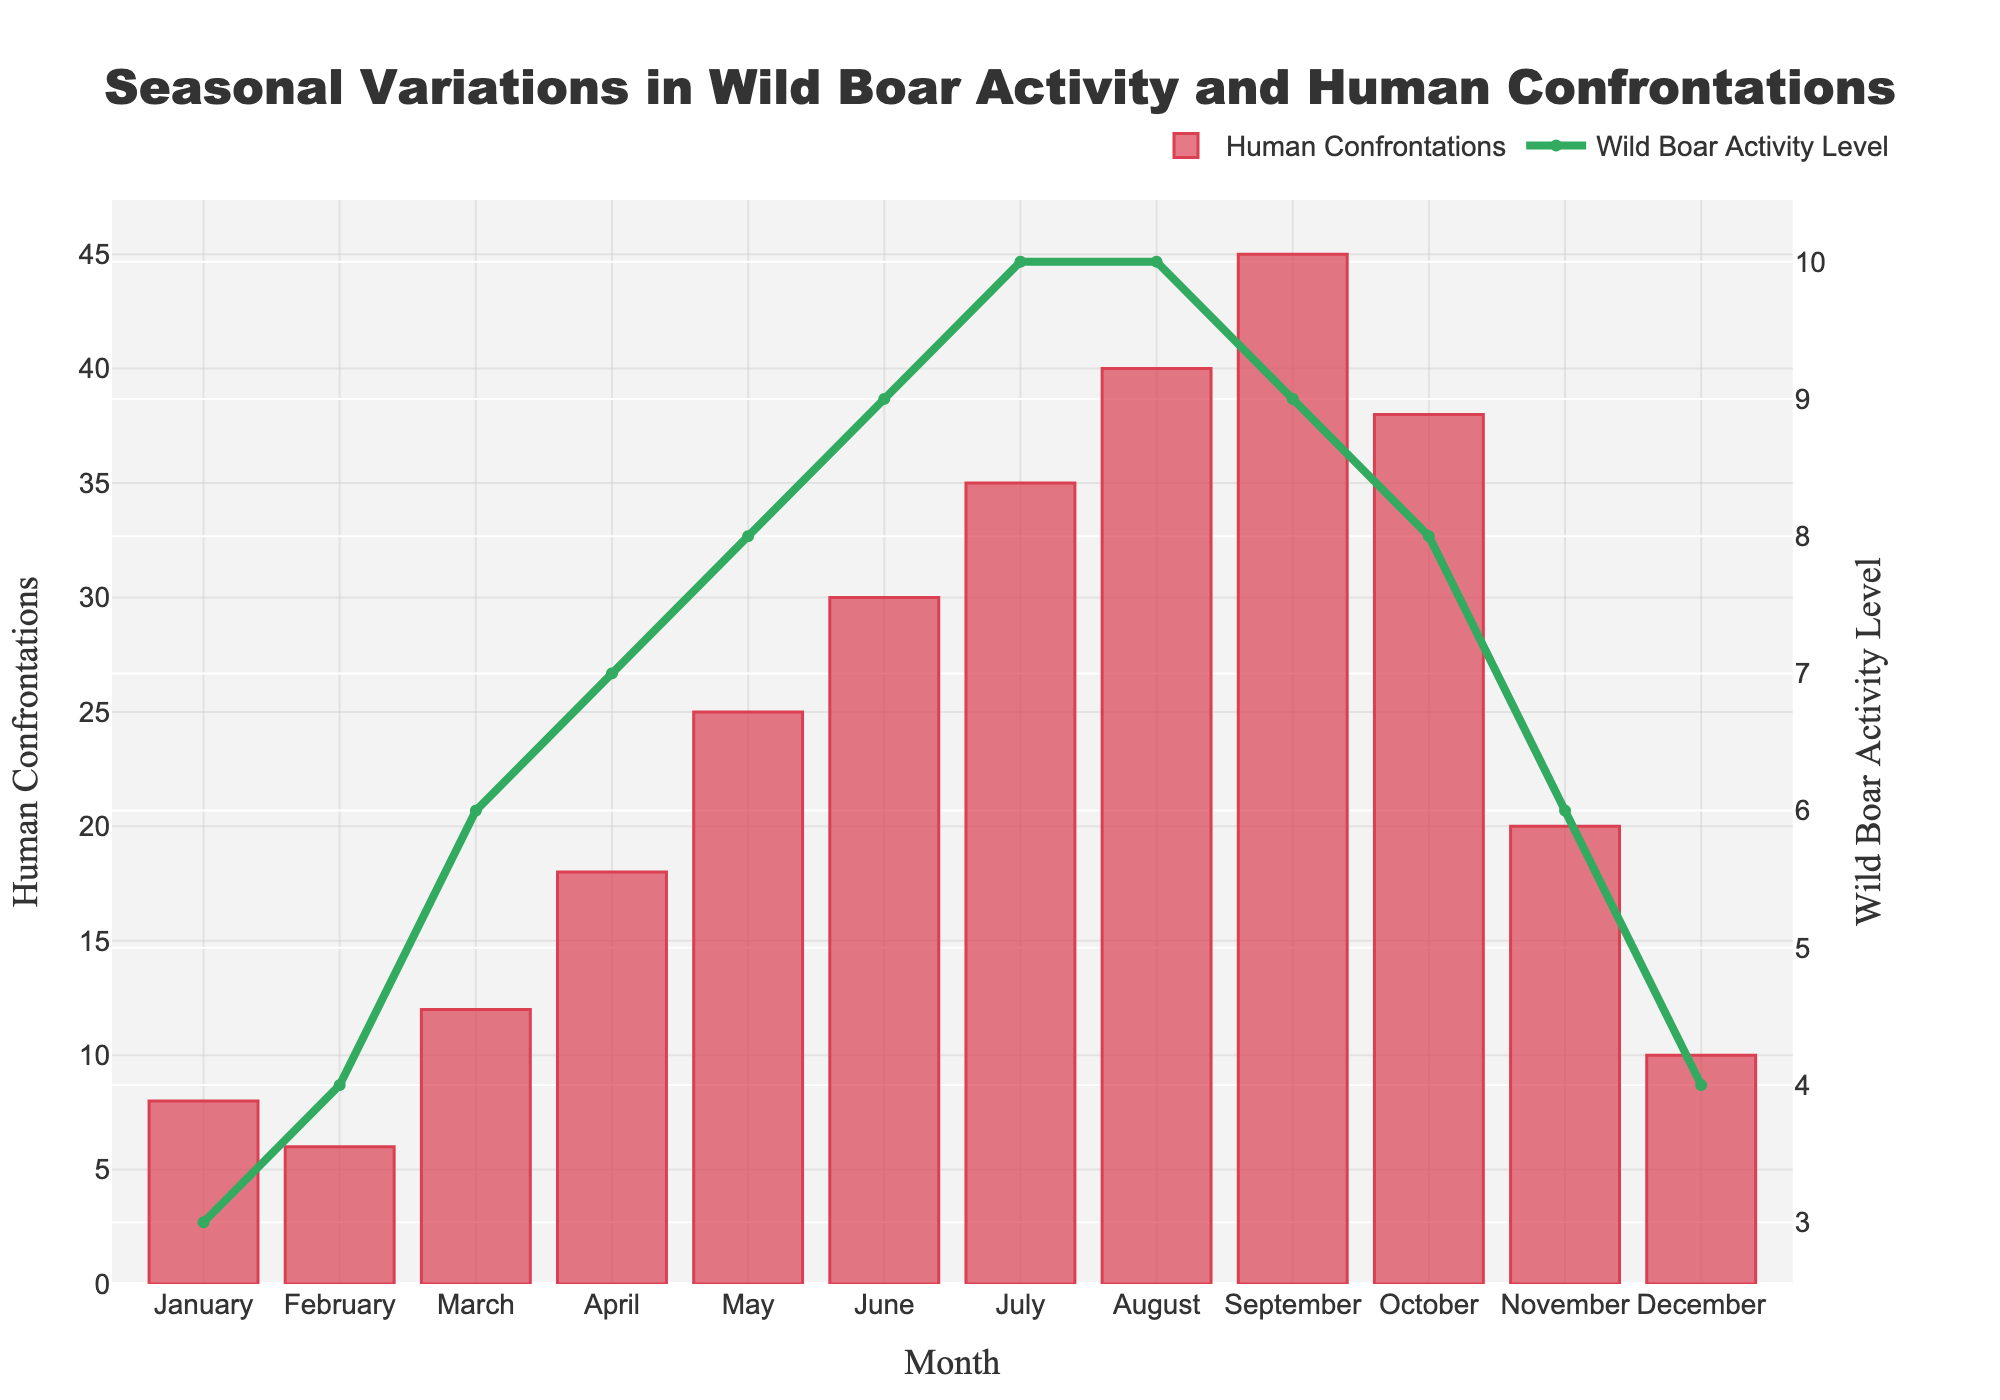What month has the highest number of human confrontations with wild boars? Look at the bar chart representing human confrontations for each month across the year. The tallest bar indicates the highest number.
Answer: September In which two consecutive months does the wild boar activity level remain the same? Examine the line graph indicating wild boar activity levels and find two consecutive points which lie on the same horizontal level.
Answer: July and August By what amount do human confrontations increase from January to February? Subtract the value for January from the value for February in the human confrontations bar chart.
Answer: -2 What is the average wild boar activity level for the months of June, July, and August? Sum the wild boar activity levels for June, July, and August and then divide by 3. (9 + 10 + 10) / 3 = 9.67
Answer: 9.67 Compare the human confrontations in March and October. Which month had more confrontations and by how much? Look at the bar heights for March and October and subtract the smaller from the larger. October: 38; March: 12; Difference: 38 - 12 = 26
Answer: October by 26 What is the difference in wild boar activity levels between April and November? Subtract the wild boar activity level for November from that of April. April: 7; November: 6; Difference: 7 - 6 = 1
Answer: 1 